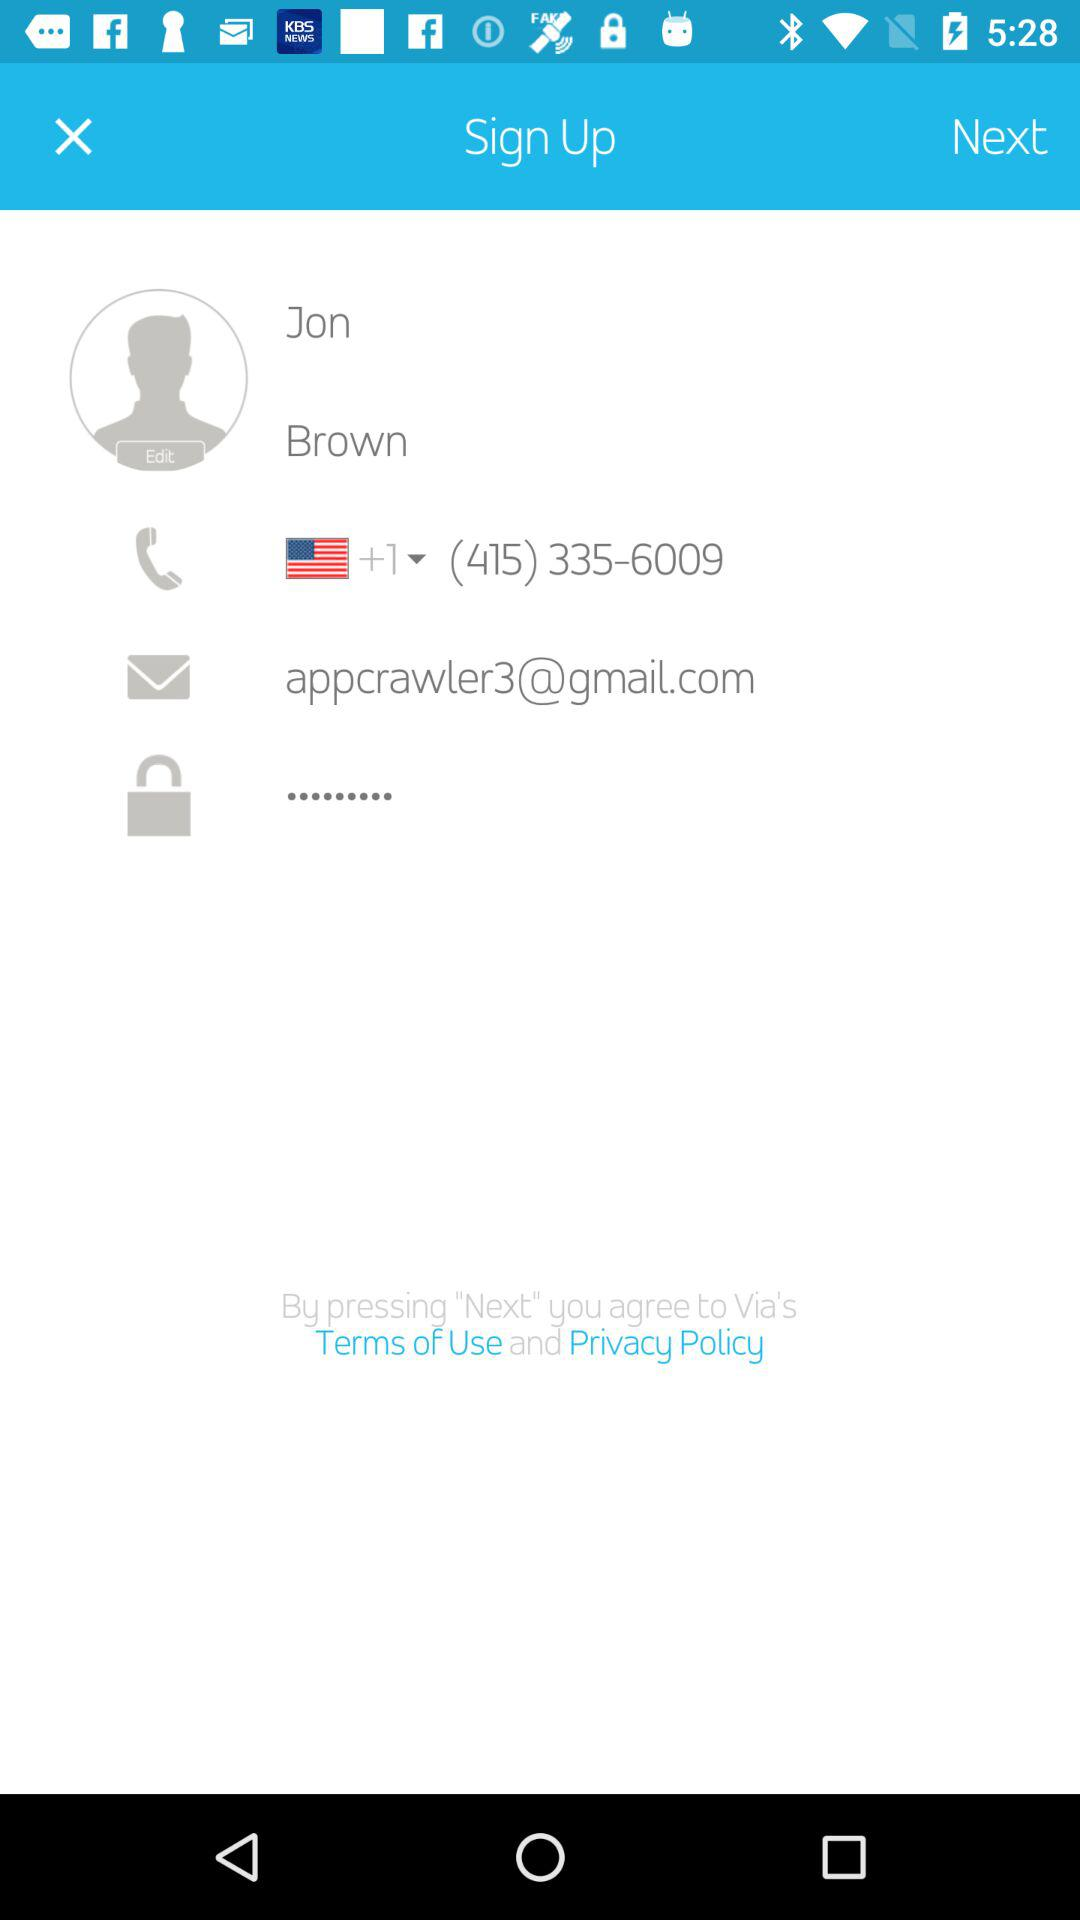What is the email address? The email address is appcrawler3@gmail.com. 